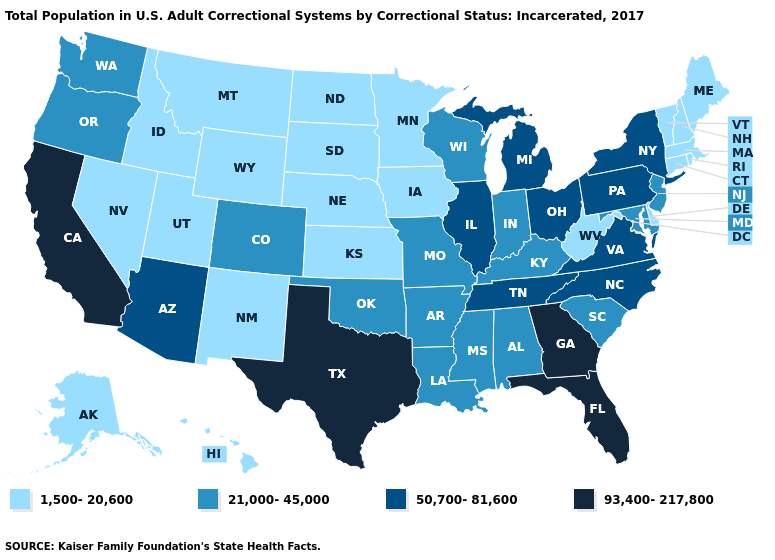Does Florida have the highest value in the South?
Answer briefly. Yes. Name the states that have a value in the range 93,400-217,800?
Short answer required. California, Florida, Georgia, Texas. Does the map have missing data?
Be succinct. No. Does the map have missing data?
Keep it brief. No. Which states have the lowest value in the USA?
Short answer required. Alaska, Connecticut, Delaware, Hawaii, Idaho, Iowa, Kansas, Maine, Massachusetts, Minnesota, Montana, Nebraska, Nevada, New Hampshire, New Mexico, North Dakota, Rhode Island, South Dakota, Utah, Vermont, West Virginia, Wyoming. Does Nevada have the highest value in the USA?
Quick response, please. No. Which states hav the highest value in the West?
Quick response, please. California. Does Wisconsin have the same value as California?
Quick response, please. No. Does South Dakota have the lowest value in the USA?
Concise answer only. Yes. Among the states that border Arizona , which have the highest value?
Concise answer only. California. Does Louisiana have a higher value than Delaware?
Concise answer only. Yes. What is the value of North Dakota?
Short answer required. 1,500-20,600. Does the map have missing data?
Give a very brief answer. No. 